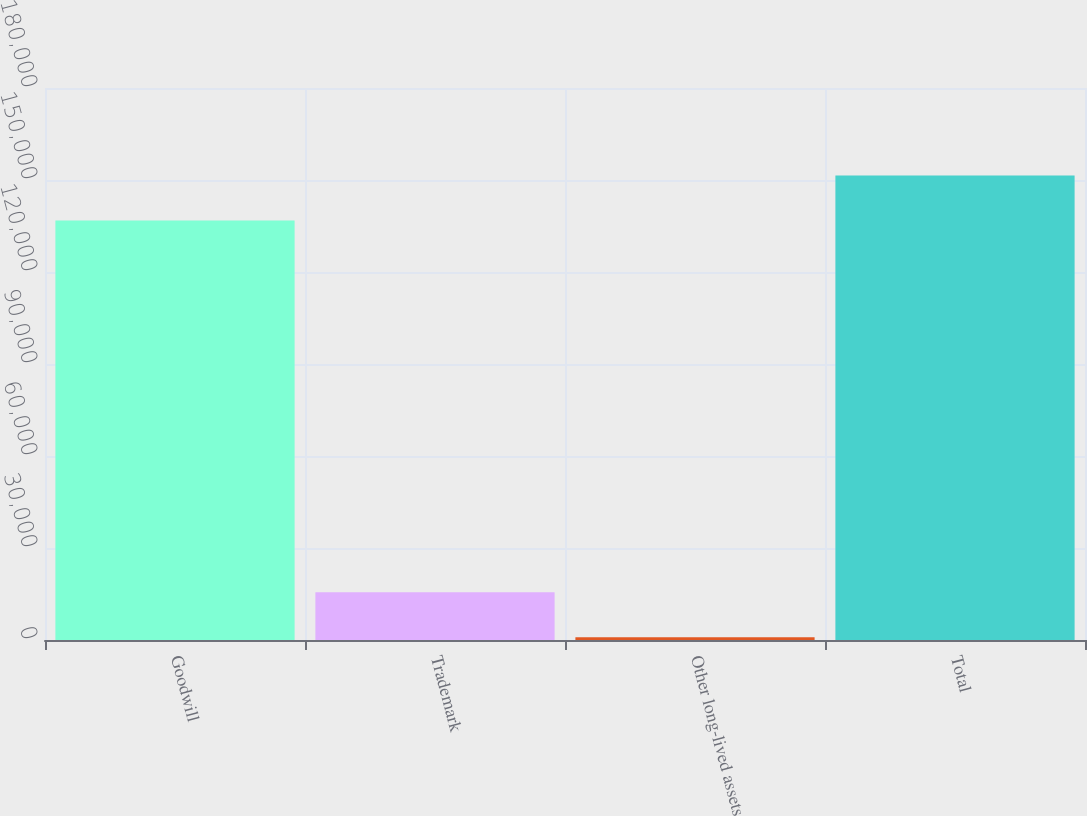<chart> <loc_0><loc_0><loc_500><loc_500><bar_chart><fcel>Goodwill<fcel>Trademark<fcel>Other long-lived assets<fcel>Total<nl><fcel>136800<fcel>15544<fcel>864<fcel>151480<nl></chart> 